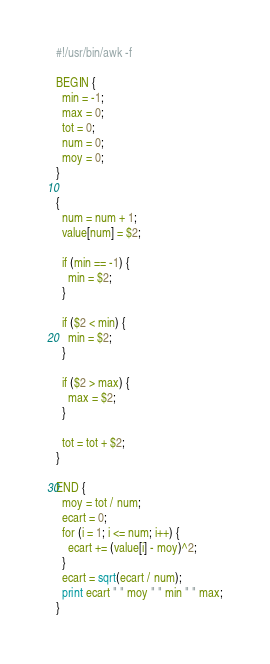<code> <loc_0><loc_0><loc_500><loc_500><_Awk_>#!/usr/bin/awk -f 

BEGIN {
  min = -1;
  max = 0;
  tot = 0;
  num = 0;
  moy = 0;
}

{
  num = num + 1;
  value[num] = $2;

  if (min == -1) {
    min = $2;
  }
  
  if ($2 < min) {
    min = $2;  
  }

  if ($2 > max) {
    max = $2;
  }

  tot = tot + $2;
}

END {
  moy = tot / num;
  ecart = 0;
  for (i = 1; i <= num; i++) {
    ecart += (value[i] - moy)^2;
  }
  ecart = sqrt(ecart / num);
  print ecart " " moy " " min " " max;
}
</code> 